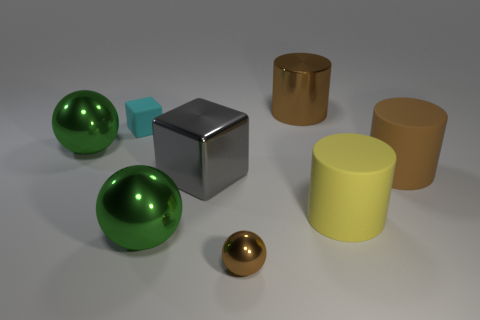Add 1 tiny rubber blocks. How many objects exist? 9 Subtract all blocks. How many objects are left? 6 Add 5 large yellow matte cylinders. How many large yellow matte cylinders exist? 6 Subtract 0 gray balls. How many objects are left? 8 Subtract all tiny red metal balls. Subtract all large cylinders. How many objects are left? 5 Add 3 brown metallic cylinders. How many brown metallic cylinders are left? 4 